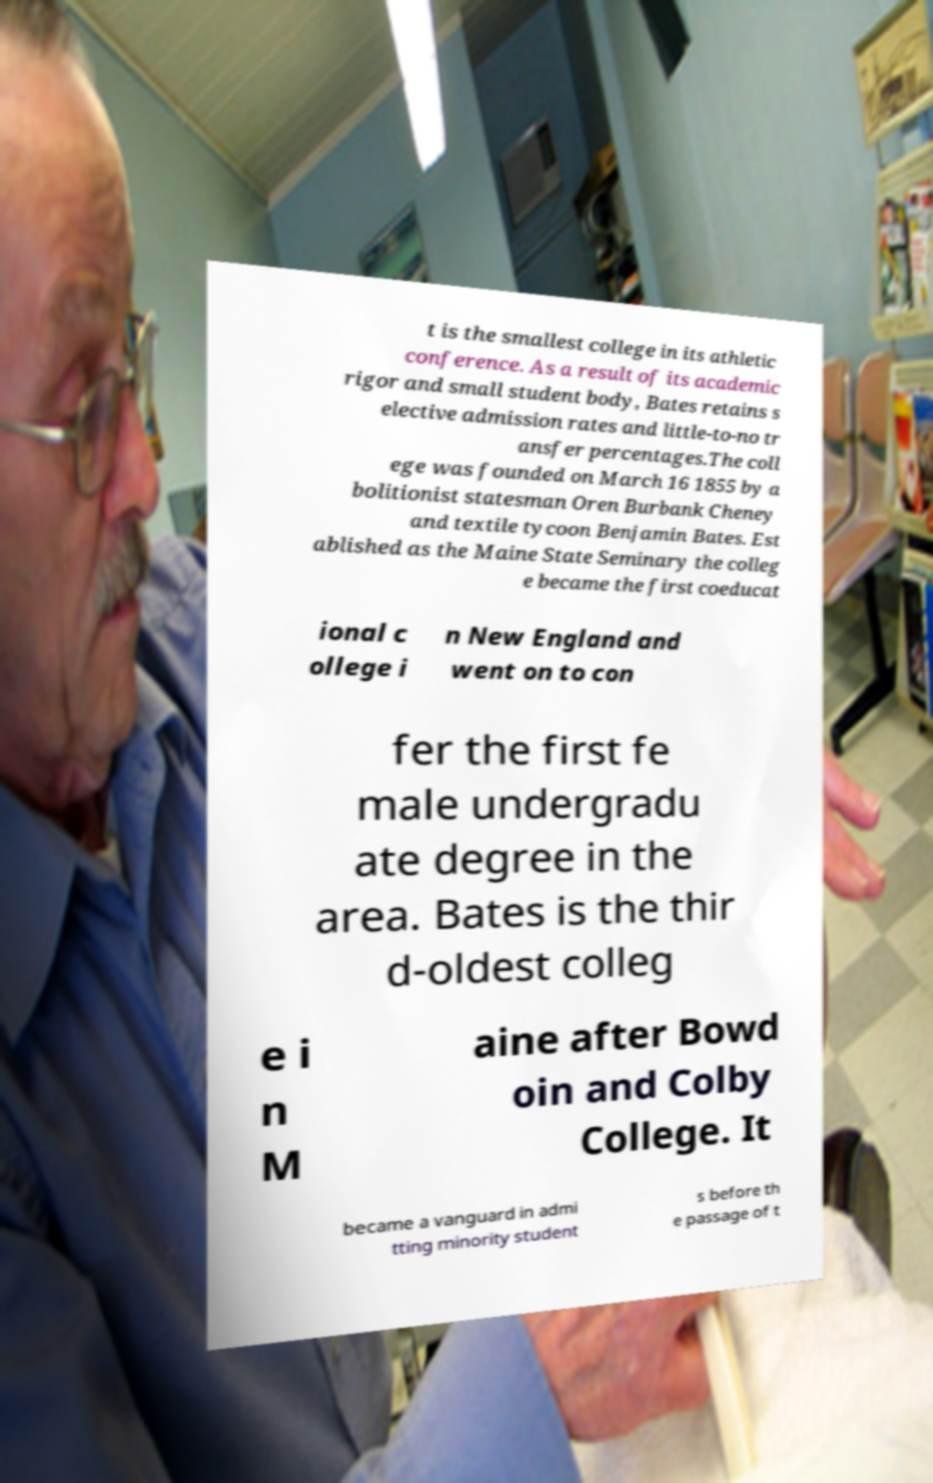Can you accurately transcribe the text from the provided image for me? t is the smallest college in its athletic conference. As a result of its academic rigor and small student body, Bates retains s elective admission rates and little-to-no tr ansfer percentages.The coll ege was founded on March 16 1855 by a bolitionist statesman Oren Burbank Cheney and textile tycoon Benjamin Bates. Est ablished as the Maine State Seminary the colleg e became the first coeducat ional c ollege i n New England and went on to con fer the first fe male undergradu ate degree in the area. Bates is the thir d-oldest colleg e i n M aine after Bowd oin and Colby College. It became a vanguard in admi tting minority student s before th e passage of t 